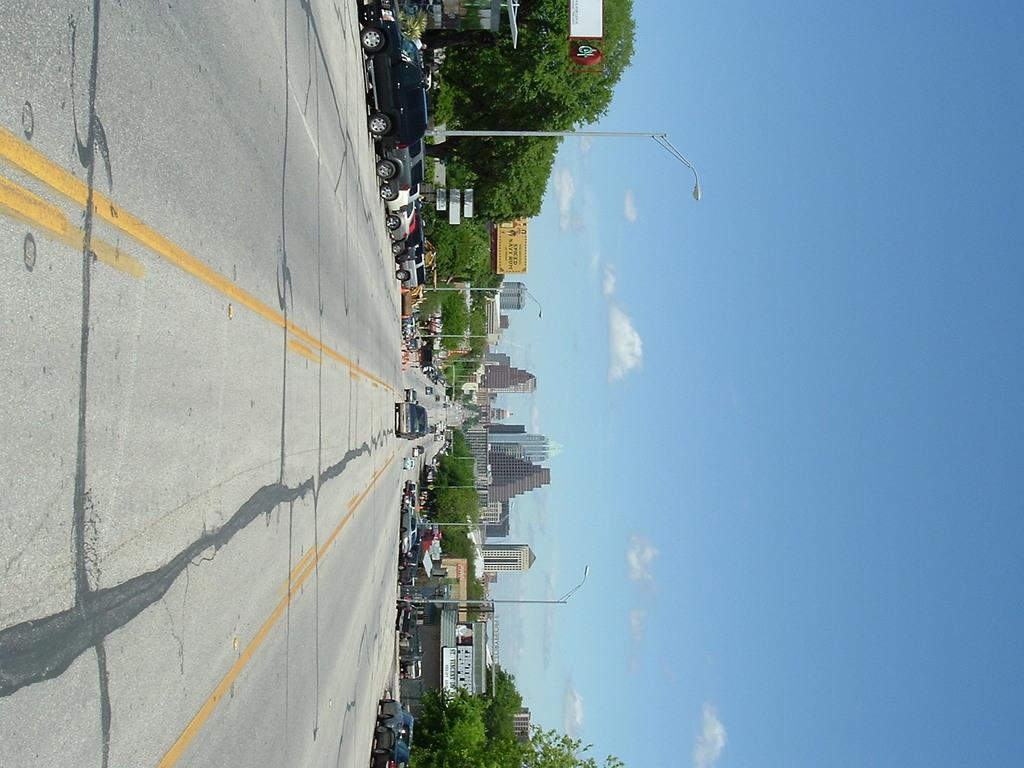What is the main feature in the center of the image? There is a road in the center of the image. What is happening on the road? Vehicles are present on the road. What can be seen in the background of the image? There are buildings, poles, and trees in the background of the image. What is visible at the top of the image? The sky is visible at the top of the image. How does the yoke help the vehicles on the road in the image? There is no yoke present in the image, and therefore it cannot help the vehicles on the road. 